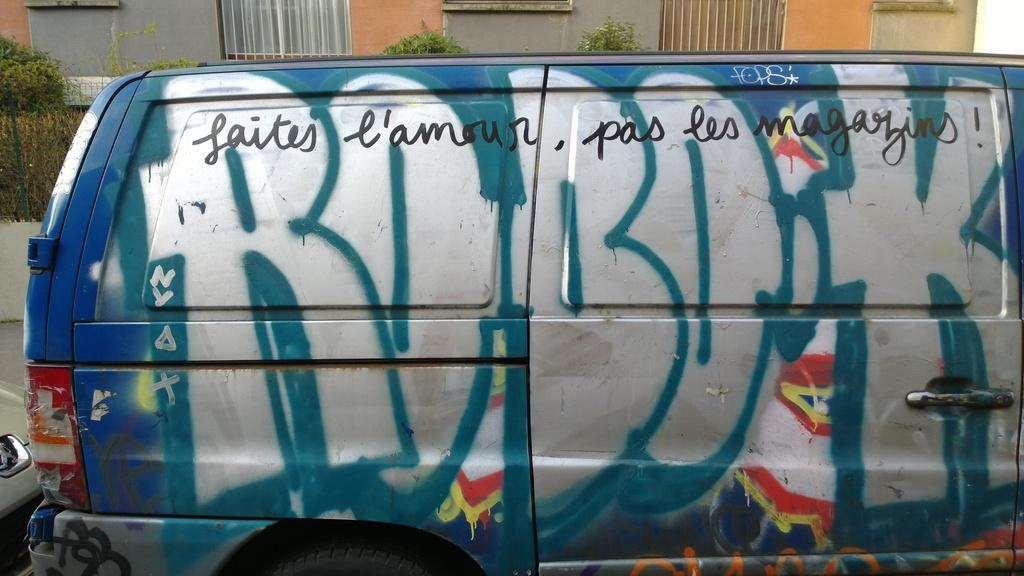<image>
Create a compact narrative representing the image presented. A truck with graffiti written on it says ROBOK 